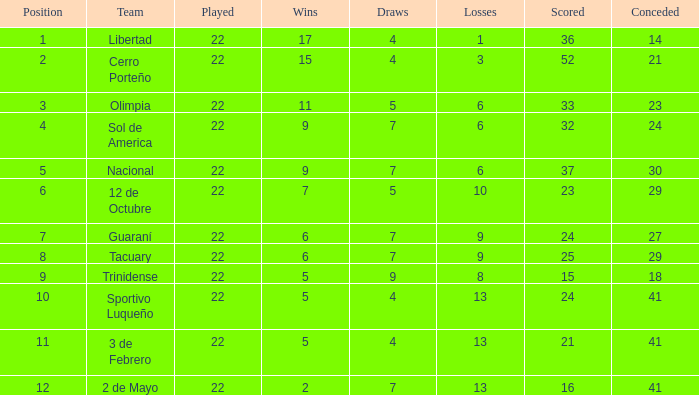What is the number of draws for the team with more than 8 losses and 13 points? 7.0. 